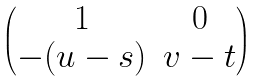<formula> <loc_0><loc_0><loc_500><loc_500>\begin{pmatrix} 1 & 0 \\ - ( u - s ) & v - t \end{pmatrix}</formula> 